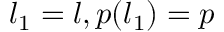Convert formula to latex. <formula><loc_0><loc_0><loc_500><loc_500>l _ { 1 } = l , p ( l _ { 1 } ) = p</formula> 